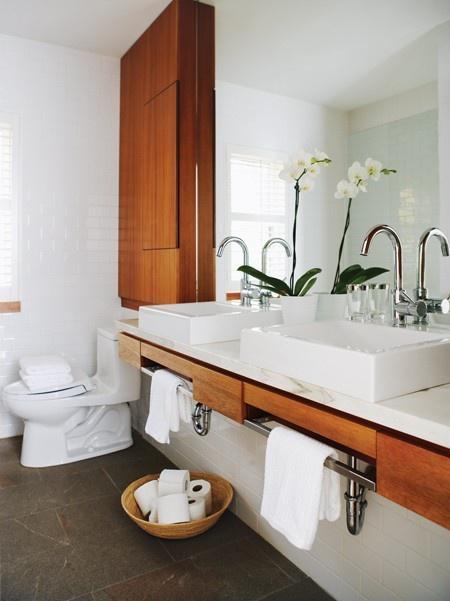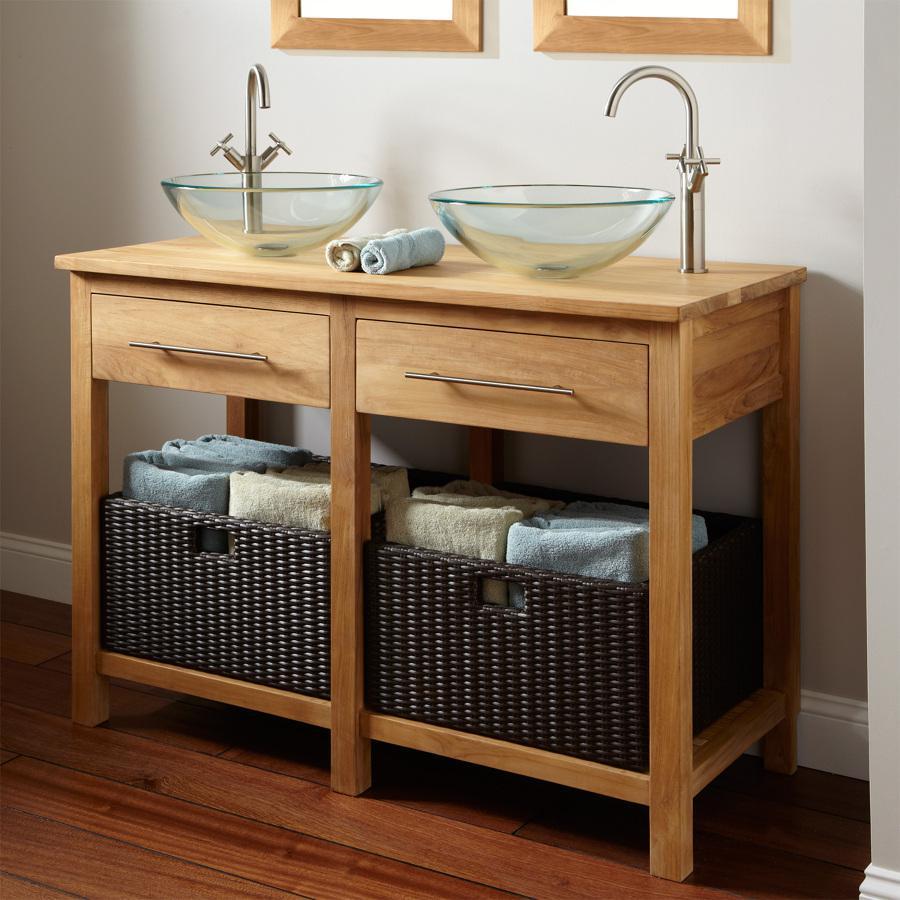The first image is the image on the left, the second image is the image on the right. Examine the images to the left and right. Is the description "a toilet can be seen" accurate? Answer yes or no. Yes. The first image is the image on the left, the second image is the image on the right. Given the left and right images, does the statement "All of the bathrooms have double sinks." hold true? Answer yes or no. Yes. 